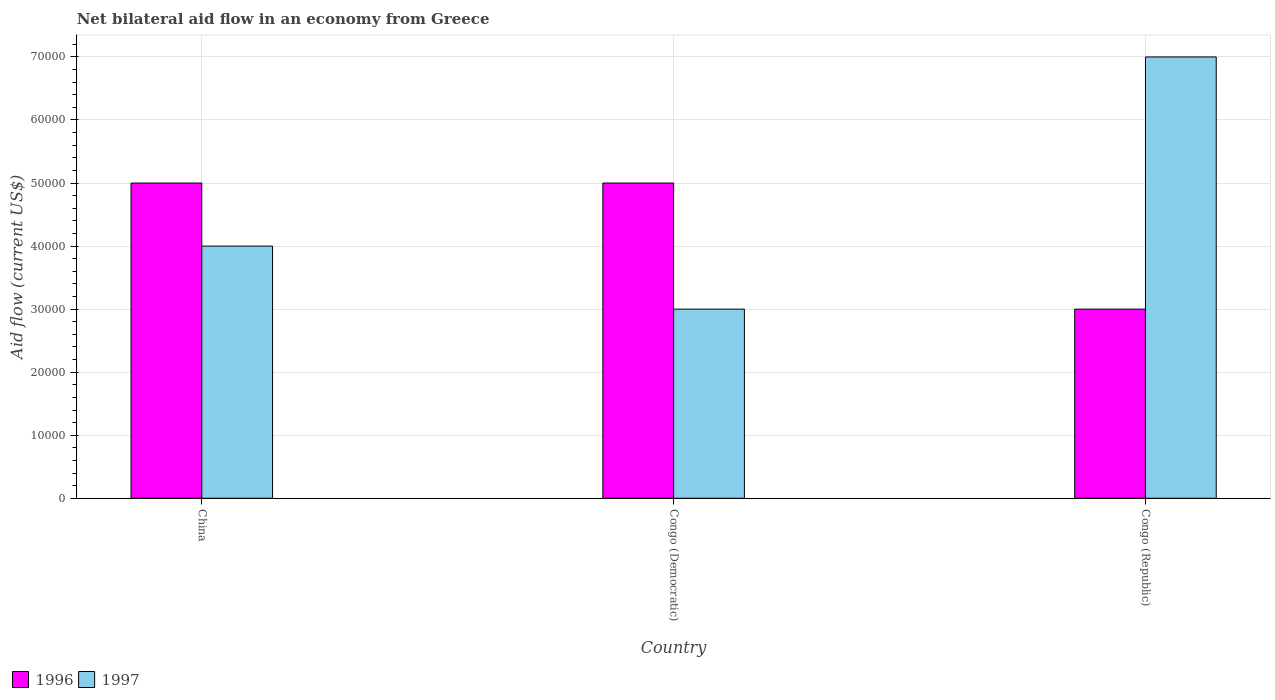Are the number of bars on each tick of the X-axis equal?
Offer a terse response. Yes. How many bars are there on the 1st tick from the left?
Give a very brief answer. 2. How many bars are there on the 1st tick from the right?
Ensure brevity in your answer.  2. What is the label of the 2nd group of bars from the left?
Ensure brevity in your answer.  Congo (Democratic). In which country was the net bilateral aid flow in 1996 minimum?
Offer a terse response. Congo (Republic). What is the total net bilateral aid flow in 1997 in the graph?
Ensure brevity in your answer.  1.40e+05. What is the average net bilateral aid flow in 1996 per country?
Give a very brief answer. 4.33e+04. What is the difference between the net bilateral aid flow of/in 1996 and net bilateral aid flow of/in 1997 in Congo (Democratic)?
Your answer should be compact. 2.00e+04. What is the ratio of the net bilateral aid flow in 1997 in China to that in Congo (Democratic)?
Your answer should be very brief. 1.33. Is the net bilateral aid flow in 1996 in China less than that in Congo (Republic)?
Provide a succinct answer. No. What is the difference between the highest and the second highest net bilateral aid flow in 1997?
Provide a succinct answer. 4.00e+04. What is the difference between the highest and the lowest net bilateral aid flow in 1996?
Provide a short and direct response. 2.00e+04. In how many countries, is the net bilateral aid flow in 1997 greater than the average net bilateral aid flow in 1997 taken over all countries?
Offer a terse response. 1. Are all the bars in the graph horizontal?
Give a very brief answer. No. What is the difference between two consecutive major ticks on the Y-axis?
Your response must be concise. 10000. Are the values on the major ticks of Y-axis written in scientific E-notation?
Provide a succinct answer. No. Does the graph contain any zero values?
Give a very brief answer. No. Does the graph contain grids?
Make the answer very short. Yes. Where does the legend appear in the graph?
Offer a very short reply. Bottom left. How many legend labels are there?
Give a very brief answer. 2. How are the legend labels stacked?
Your response must be concise. Horizontal. What is the title of the graph?
Keep it short and to the point. Net bilateral aid flow in an economy from Greece. What is the label or title of the X-axis?
Ensure brevity in your answer.  Country. What is the Aid flow (current US$) of 1996 in China?
Offer a very short reply. 5.00e+04. What is the Aid flow (current US$) in 1997 in China?
Your response must be concise. 4.00e+04. What is the Aid flow (current US$) in 1996 in Congo (Republic)?
Provide a short and direct response. 3.00e+04. Across all countries, what is the minimum Aid flow (current US$) in 1996?
Keep it short and to the point. 3.00e+04. Across all countries, what is the minimum Aid flow (current US$) of 1997?
Keep it short and to the point. 3.00e+04. What is the total Aid flow (current US$) in 1996 in the graph?
Make the answer very short. 1.30e+05. What is the total Aid flow (current US$) in 1997 in the graph?
Offer a terse response. 1.40e+05. What is the difference between the Aid flow (current US$) of 1996 in China and that in Congo (Democratic)?
Your answer should be compact. 0. What is the difference between the Aid flow (current US$) in 1997 in China and that in Congo (Democratic)?
Keep it short and to the point. 10000. What is the difference between the Aid flow (current US$) of 1996 in Congo (Democratic) and that in Congo (Republic)?
Keep it short and to the point. 2.00e+04. What is the difference between the Aid flow (current US$) in 1996 in China and the Aid flow (current US$) in 1997 in Congo (Republic)?
Give a very brief answer. -2.00e+04. What is the difference between the Aid flow (current US$) of 1996 in Congo (Democratic) and the Aid flow (current US$) of 1997 in Congo (Republic)?
Give a very brief answer. -2.00e+04. What is the average Aid flow (current US$) in 1996 per country?
Your response must be concise. 4.33e+04. What is the average Aid flow (current US$) in 1997 per country?
Your answer should be compact. 4.67e+04. What is the difference between the Aid flow (current US$) of 1996 and Aid flow (current US$) of 1997 in China?
Provide a succinct answer. 10000. What is the difference between the Aid flow (current US$) in 1996 and Aid flow (current US$) in 1997 in Congo (Democratic)?
Make the answer very short. 2.00e+04. What is the difference between the Aid flow (current US$) of 1996 and Aid flow (current US$) of 1997 in Congo (Republic)?
Your answer should be very brief. -4.00e+04. What is the ratio of the Aid flow (current US$) in 1997 in China to that in Congo (Democratic)?
Keep it short and to the point. 1.33. What is the ratio of the Aid flow (current US$) of 1996 in China to that in Congo (Republic)?
Ensure brevity in your answer.  1.67. What is the ratio of the Aid flow (current US$) in 1997 in China to that in Congo (Republic)?
Keep it short and to the point. 0.57. What is the ratio of the Aid flow (current US$) in 1997 in Congo (Democratic) to that in Congo (Republic)?
Ensure brevity in your answer.  0.43. What is the difference between the highest and the second highest Aid flow (current US$) of 1996?
Offer a terse response. 0. What is the difference between the highest and the lowest Aid flow (current US$) of 1997?
Make the answer very short. 4.00e+04. 